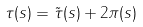Convert formula to latex. <formula><loc_0><loc_0><loc_500><loc_500>\tau ( s ) = \tilde { \tau } ( s ) + 2 \pi ( s )</formula> 